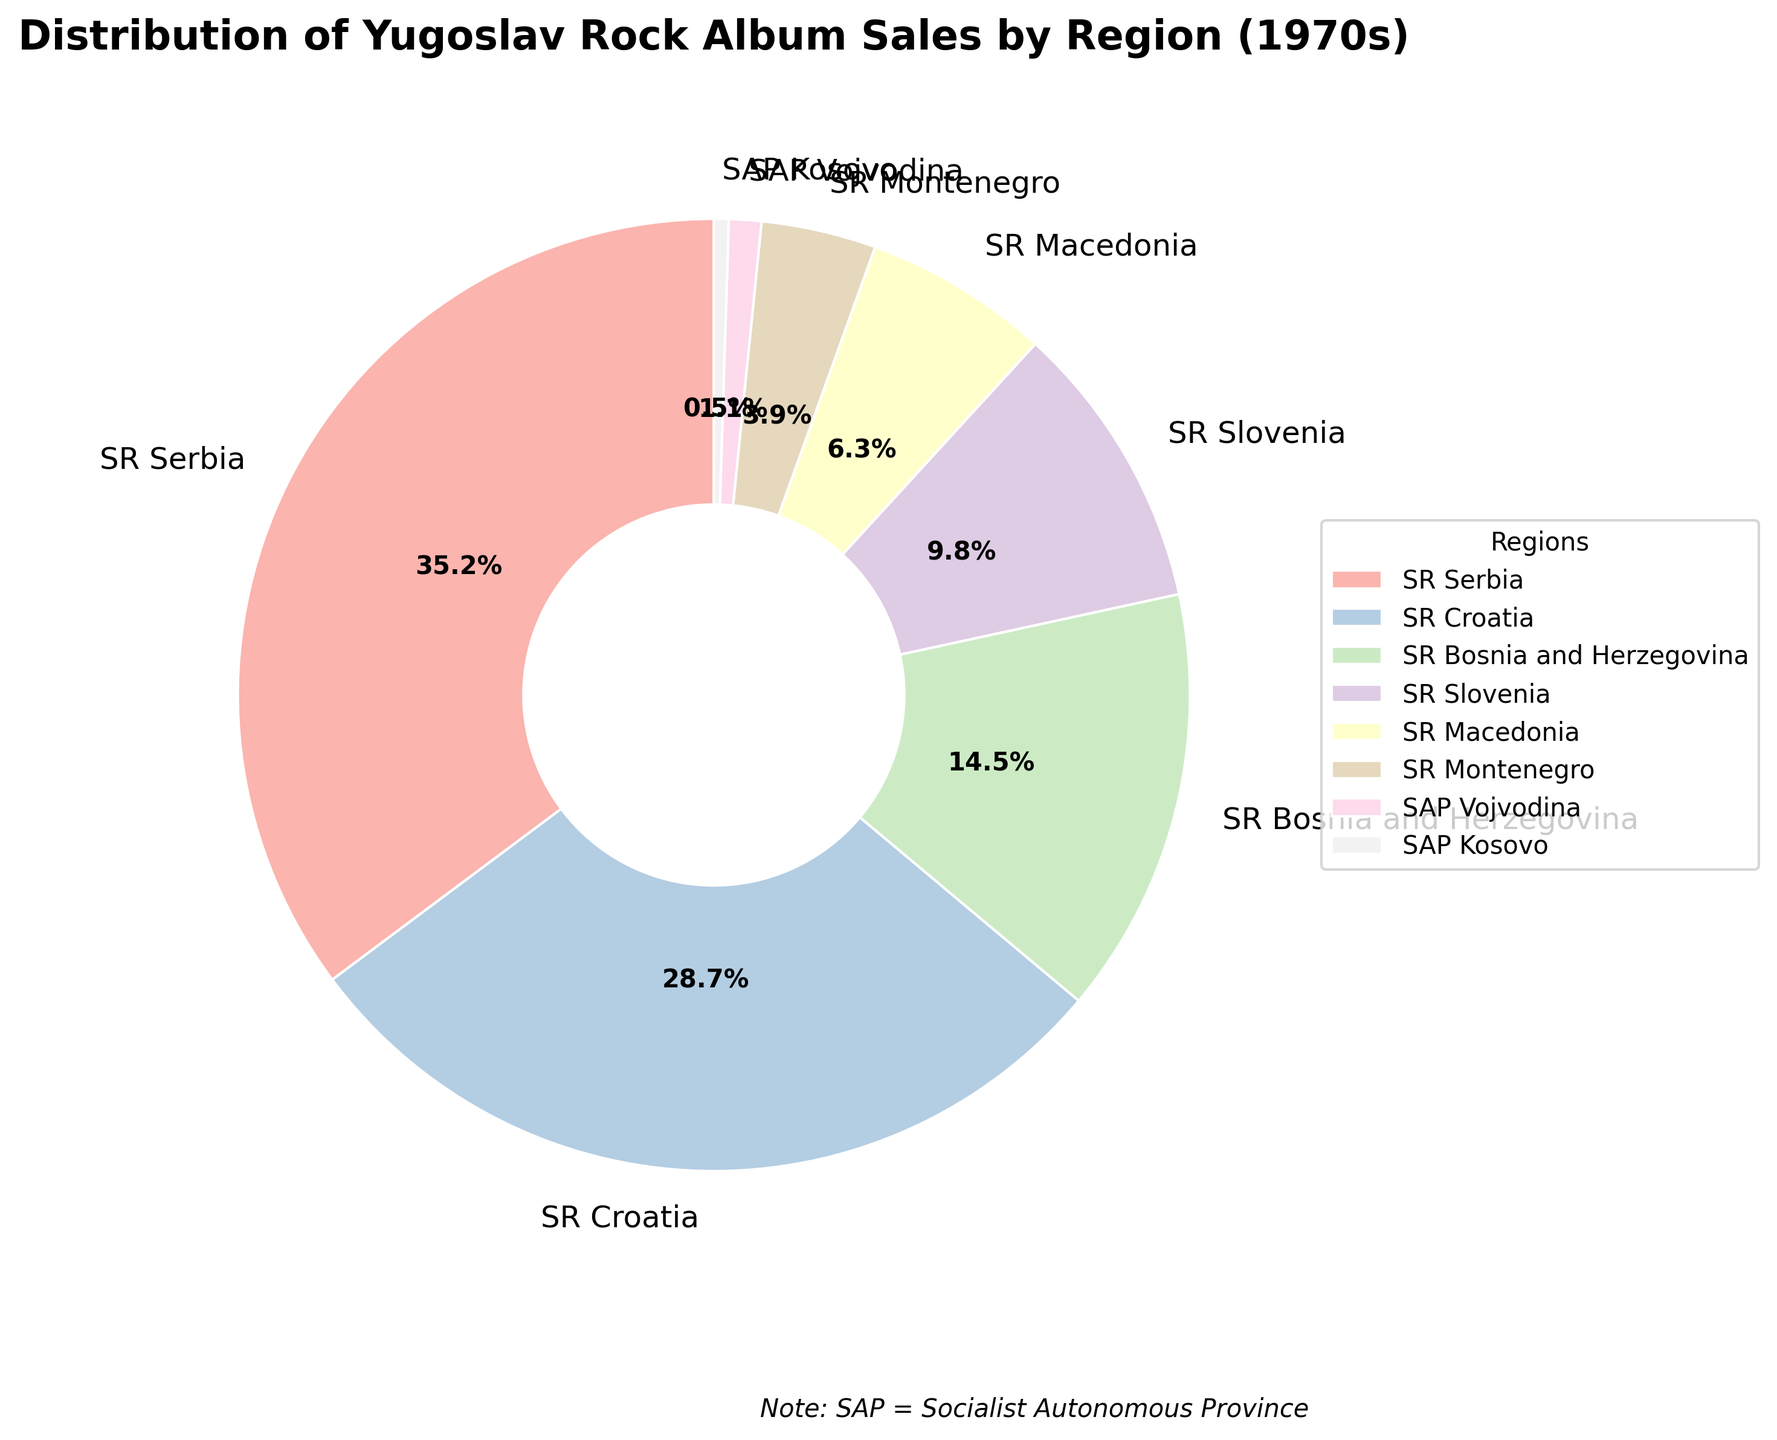Which region has the highest percentage of album sales? SR Serbia has the highest percentage of album sales as it is shown with the largest wedge in the pie chart.
Answer: SR Serbia Which region has the lowest percentage of album sales? SAP Kosovo has the lowest percentage, visible as the smallest wedge in the pie chart.
Answer: SAP Kosovo What is the combined album sales percentage of SR Croatia and SR Bosnia and Herzegovina? Adding the percentages of SR Croatia (28.7%) and SR Bosnia and Herzegovina (14.5%), we get 28.7 + 14.5 = 43.2%.
Answer: 43.2% How much greater is the album sales percentage of SR Slovenia compared to SR Montenegro? SR Slovenia has an album sales percentage of 9.8% while SR Montenegro has 3.9%. Subtracting these, 9.8 - 3.9 = 5.9%.
Answer: 5.9% Is the sales percentage of SR Macedonia greater or smaller than half of SR Serbia's sales percentage? Half of SR Serbia's sales percentage is 35.2 / 2 = 17.6%. SR Macedonia's sales percentage is 6.3%, which is smaller than 17.6%.
Answer: Smaller What is the difference in album sales percentage between SR Croatia and SR Macedonia? SR Croatia has 28.7% and SR Macedonia has 6.3%. The difference is 28.7 - 6.3 = 22.4%.
Answer: 22.4% Which regions’ album sales percentages total to more than 50% when combined? Adding the top percentages: SR Serbia (35.2%) + SR Croatia (28.7%), we get 35.2 + 28.7 = 63.9%, which is more than 50%. Therefore, combining SR Serbia and SR Croatia alone totals to more than 50%.
Answer: SR Serbia and SR Croatia How much is SR Slovenia’s album sales percentage larger than that of SAP Vojvodina and SAP Kosovo combined? SAP Vojvodina's percentage is 1.1% and SAP Kosovo's is 0.5%. Their combined percentage is 1.1 + 0.5 = 1.6%. SR Slovenia's percentage is 9.8%, so the difference is 9.8 - 1.6 = 8.2%.
Answer: 8.2% Do the regions SR Bosnia and Herzegovina, SR Macedonia, SR Montenegro, and SAP Kosovo together have more or less than SR Serbia alone? Adding the percentages: SR Bosnia and Herzegovina (14.5%) + SR Macedonia (6.3%) + SR Montenegro (3.9%) + SAP Kosovo (0.5%) = 25.2%. SR Serbia alone is 35.2%, which is more than 25.2%.
Answer: Less 